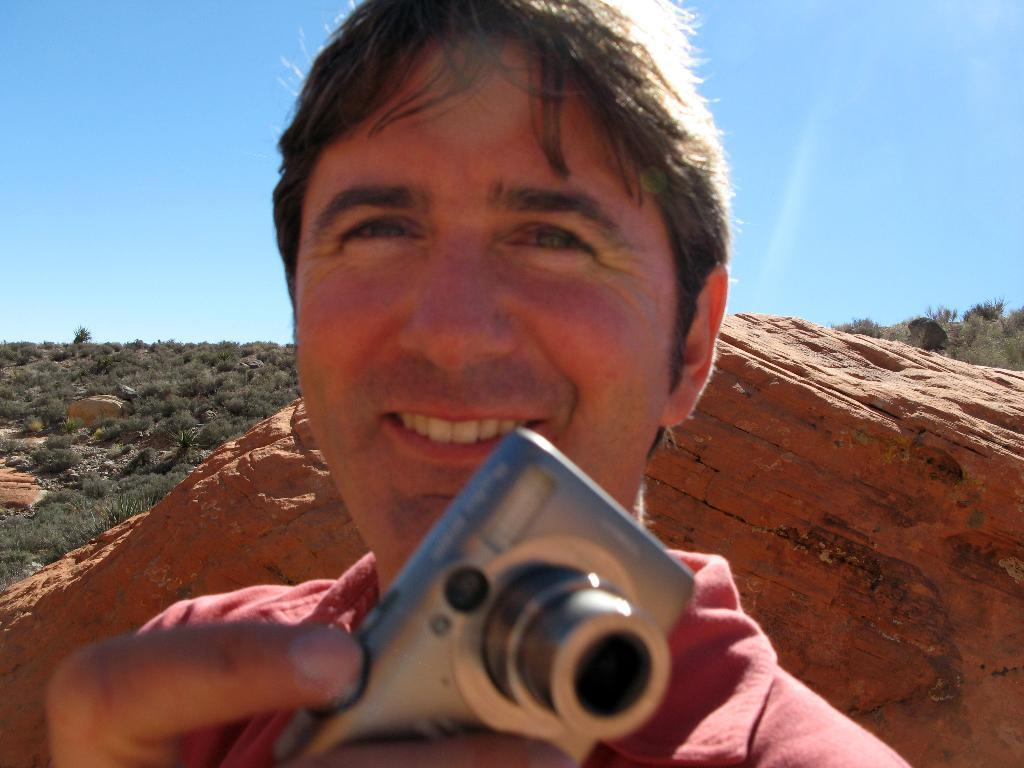What is the man in the image holding? The man is holding a camera in the image. What is the man's facial expression in the image? The man is smiling in the image. What can be seen in the background of the image? There is a rock, plants, and the sky visible in the background of the image. What rate of exchange is the man discussing with the plants in the image? There is no discussion of exchange rates in the image, as the man is holding a camera and smiling, and the plants are in the background. 